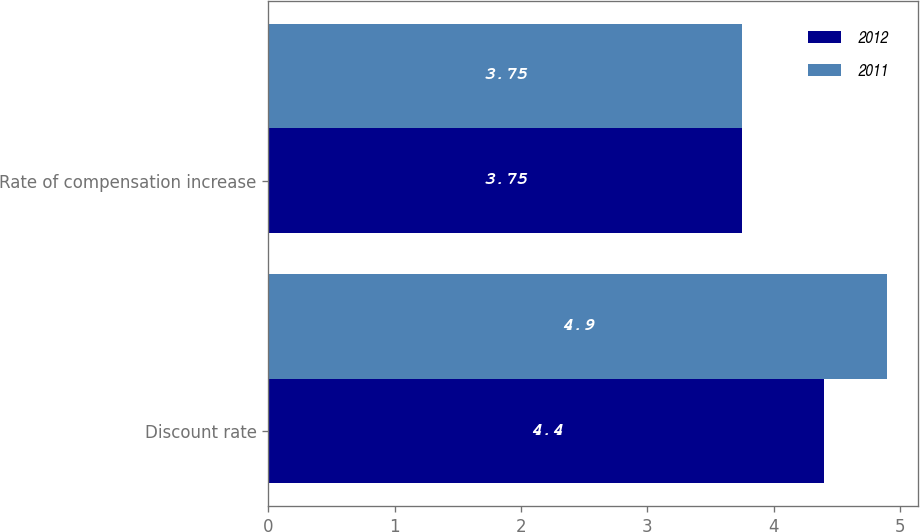Convert chart to OTSL. <chart><loc_0><loc_0><loc_500><loc_500><stacked_bar_chart><ecel><fcel>Discount rate<fcel>Rate of compensation increase<nl><fcel>2012<fcel>4.4<fcel>3.75<nl><fcel>2011<fcel>4.9<fcel>3.75<nl></chart> 